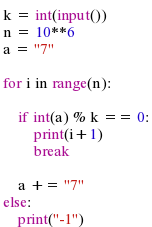<code> <loc_0><loc_0><loc_500><loc_500><_Python_>k = int(input())
n = 10**6
a = "7"

for i in range(n):

    if int(a) % k == 0:
        print(i+1)
        break

    a += "7"
else:
    print("-1")

</code> 